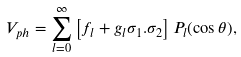Convert formula to latex. <formula><loc_0><loc_0><loc_500><loc_500>V _ { p h } = \sum _ { l = 0 } ^ { \infty } \left [ f _ { l } + g _ { l } { \sigma _ { 1 } . \sigma _ { 2 } } \right ] P _ { l } ( \cos \theta ) ,</formula> 